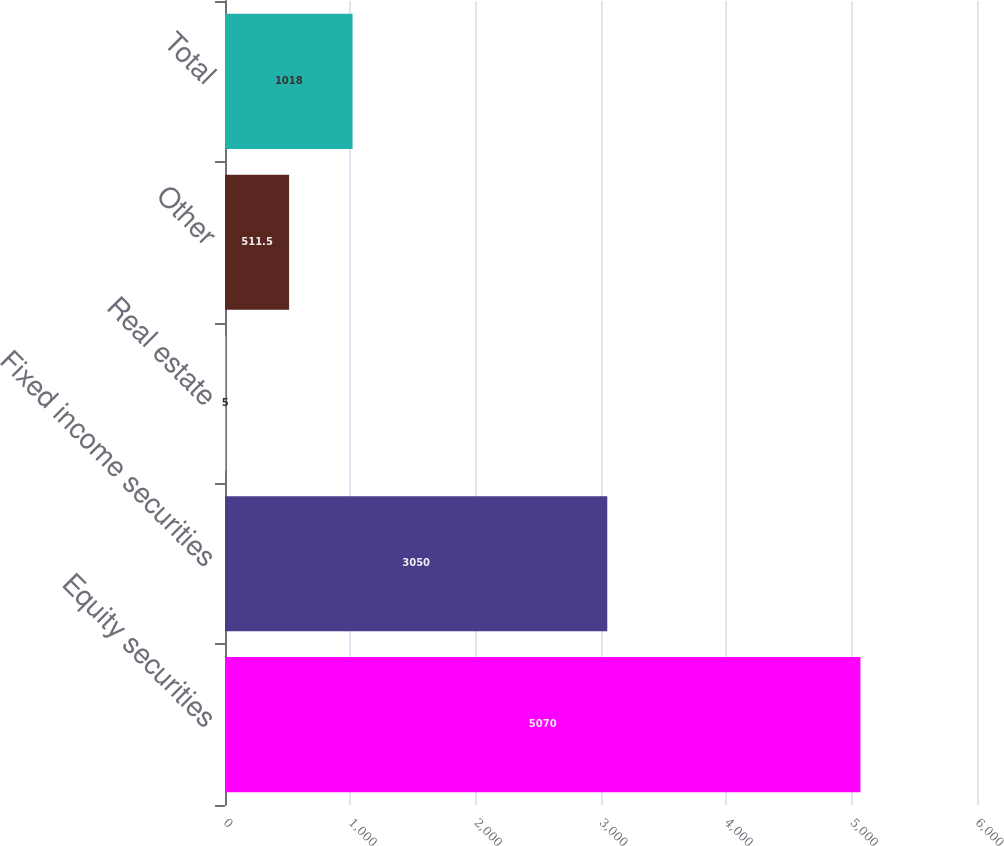Convert chart to OTSL. <chart><loc_0><loc_0><loc_500><loc_500><bar_chart><fcel>Equity securities<fcel>Fixed income securities<fcel>Real estate<fcel>Other<fcel>Total<nl><fcel>5070<fcel>3050<fcel>5<fcel>511.5<fcel>1018<nl></chart> 